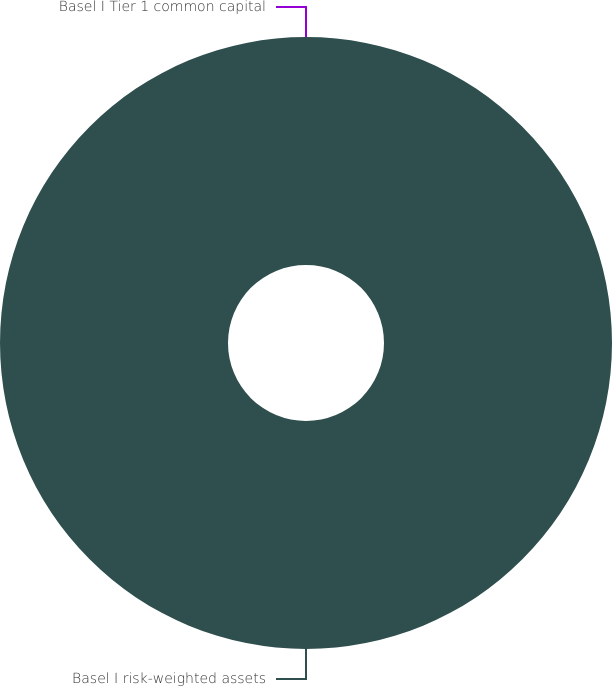Convert chart to OTSL. <chart><loc_0><loc_0><loc_500><loc_500><pie_chart><fcel>Basel I Tier 1 common capital<fcel>Basel I risk-weighted assets<nl><fcel>0.0%<fcel>100.0%<nl></chart> 